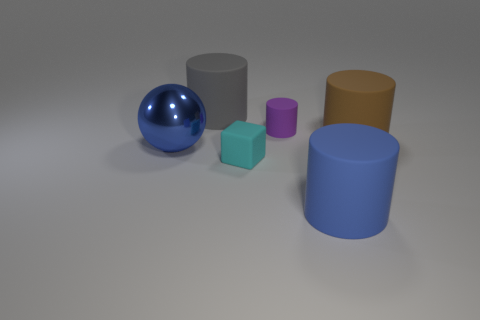Is there a blue sphere of the same size as the gray matte cylinder?
Offer a very short reply. Yes. What color is the block that is the same material as the gray object?
Provide a short and direct response. Cyan. There is a small rubber cylinder that is on the left side of the big blue cylinder; what number of blue matte cylinders are behind it?
Offer a very short reply. 0. What is the big thing that is both in front of the big brown object and to the right of the blue shiny ball made of?
Give a very brief answer. Rubber. Does the big matte thing that is behind the brown thing have the same shape as the purple matte object?
Give a very brief answer. Yes. Is the number of gray rubber blocks less than the number of rubber cylinders?
Offer a terse response. Yes. How many other big metallic balls are the same color as the metal sphere?
Provide a succinct answer. 0. There is a big metal object; is it the same color as the large cylinder that is in front of the ball?
Your response must be concise. Yes. Is the number of large rubber things greater than the number of cyan matte cubes?
Your response must be concise. Yes. What size is the blue object that is the same shape as the brown object?
Ensure brevity in your answer.  Large. 